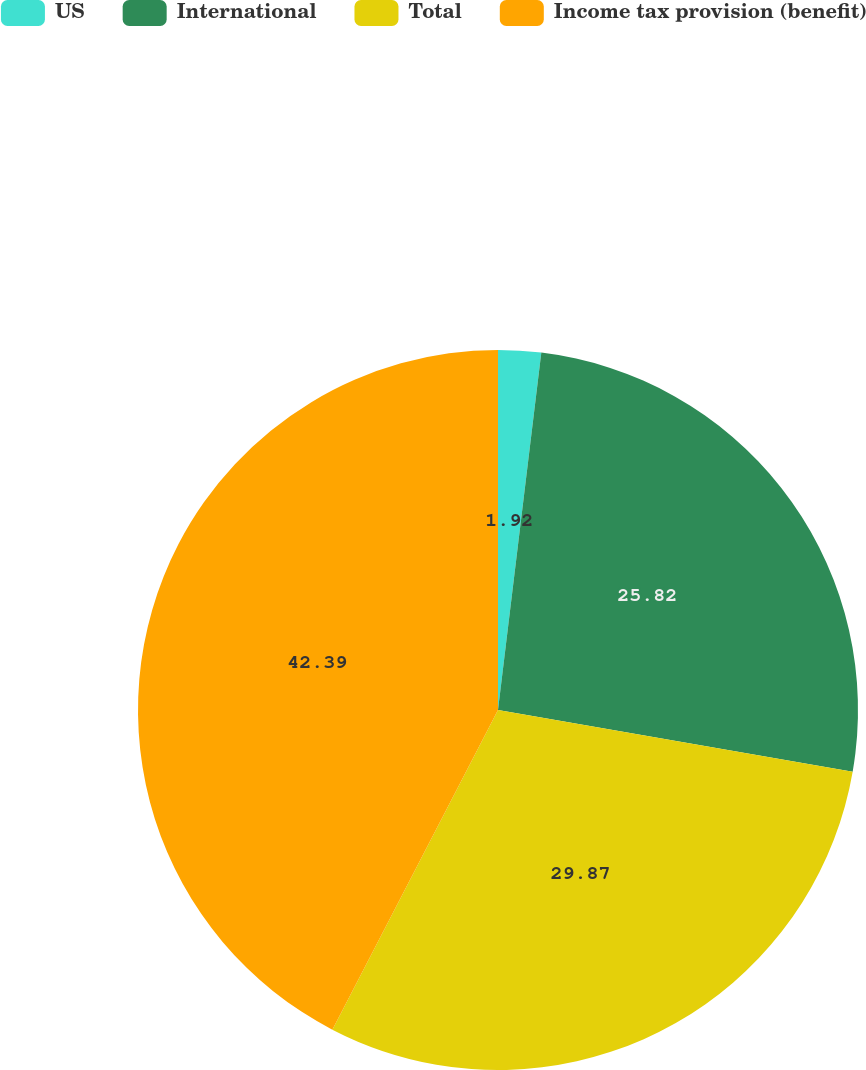Convert chart to OTSL. <chart><loc_0><loc_0><loc_500><loc_500><pie_chart><fcel>US<fcel>International<fcel>Total<fcel>Income tax provision (benefit)<nl><fcel>1.92%<fcel>25.82%<fcel>29.87%<fcel>42.39%<nl></chart> 